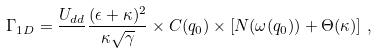<formula> <loc_0><loc_0><loc_500><loc_500>\Gamma _ { 1 D } = \frac { U _ { d d } } { } \frac { ( \epsilon + \kappa ) ^ { 2 } } { \kappa \sqrt { \gamma } } \times C ( q _ { 0 } ) \times \left [ N ( \omega ( q _ { 0 } ) ) + \Theta ( \kappa ) \right ] \, ,</formula> 